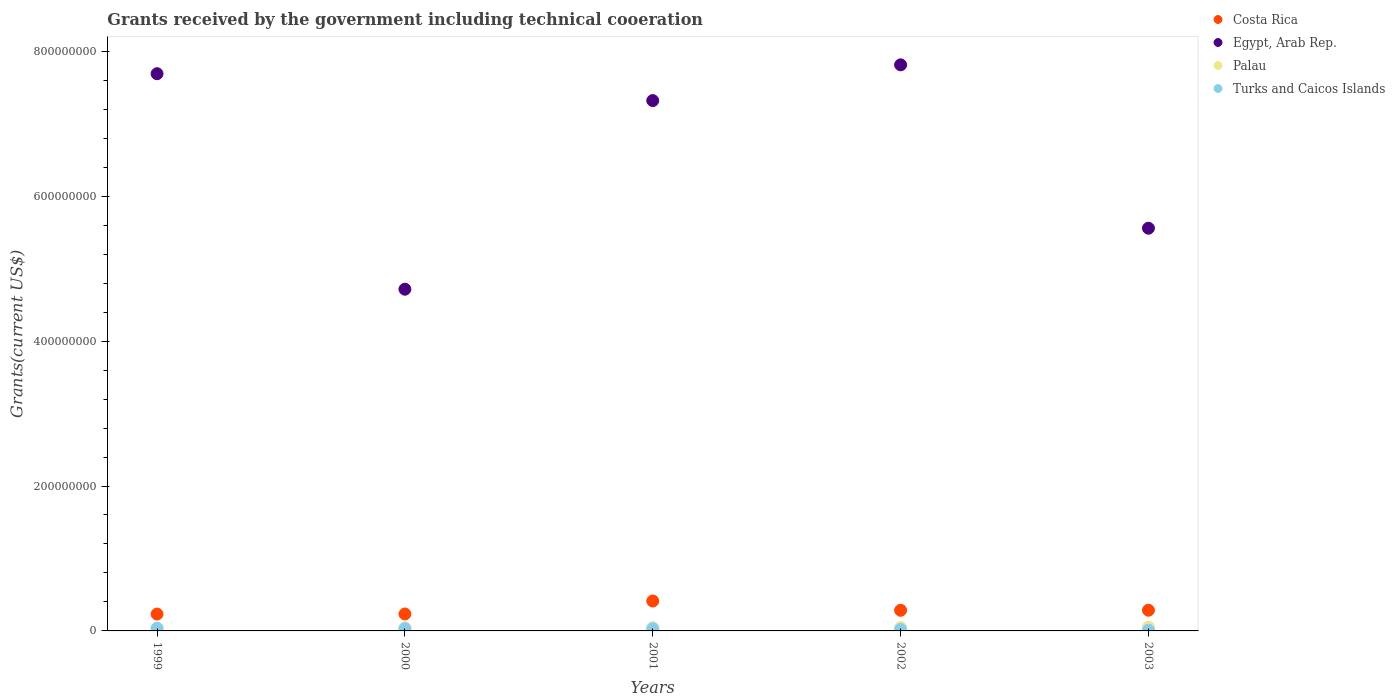Is the number of dotlines equal to the number of legend labels?
Ensure brevity in your answer.  Yes. What is the total grants received by the government in Turks and Caicos Islands in 2003?
Your answer should be very brief. 1.05e+06. Across all years, what is the maximum total grants received by the government in Egypt, Arab Rep.?
Offer a terse response. 7.81e+08. Across all years, what is the minimum total grants received by the government in Turks and Caicos Islands?
Your response must be concise. 1.05e+06. What is the total total grants received by the government in Palau in the graph?
Provide a short and direct response. 2.26e+07. What is the difference between the total grants received by the government in Turks and Caicos Islands in 2000 and that in 2001?
Your response must be concise. 1.60e+05. What is the difference between the total grants received by the government in Costa Rica in 2003 and the total grants received by the government in Egypt, Arab Rep. in 2001?
Give a very brief answer. -7.03e+08. What is the average total grants received by the government in Egypt, Arab Rep. per year?
Your answer should be compact. 6.62e+08. In the year 2000, what is the difference between the total grants received by the government in Costa Rica and total grants received by the government in Palau?
Your response must be concise. 1.92e+07. In how many years, is the total grants received by the government in Costa Rica greater than 680000000 US$?
Offer a very short reply. 0. What is the ratio of the total grants received by the government in Turks and Caicos Islands in 1999 to that in 2003?
Ensure brevity in your answer.  3.57. Is the difference between the total grants received by the government in Costa Rica in 1999 and 2000 greater than the difference between the total grants received by the government in Palau in 1999 and 2000?
Offer a terse response. Yes. What is the difference between the highest and the second highest total grants received by the government in Costa Rica?
Offer a terse response. 1.27e+07. What is the difference between the highest and the lowest total grants received by the government in Egypt, Arab Rep.?
Your response must be concise. 3.10e+08. In how many years, is the total grants received by the government in Turks and Caicos Islands greater than the average total grants received by the government in Turks and Caicos Islands taken over all years?
Provide a short and direct response. 3. Is it the case that in every year, the sum of the total grants received by the government in Costa Rica and total grants received by the government in Egypt, Arab Rep.  is greater than the total grants received by the government in Turks and Caicos Islands?
Keep it short and to the point. Yes. Does the total grants received by the government in Turks and Caicos Islands monotonically increase over the years?
Make the answer very short. No. Is the total grants received by the government in Egypt, Arab Rep. strictly less than the total grants received by the government in Palau over the years?
Offer a very short reply. No. How many dotlines are there?
Give a very brief answer. 4. How many years are there in the graph?
Keep it short and to the point. 5. What is the difference between two consecutive major ticks on the Y-axis?
Make the answer very short. 2.00e+08. Does the graph contain any zero values?
Offer a very short reply. No. Where does the legend appear in the graph?
Your answer should be compact. Top right. How many legend labels are there?
Offer a very short reply. 4. How are the legend labels stacked?
Your answer should be very brief. Vertical. What is the title of the graph?
Keep it short and to the point. Grants received by the government including technical cooeration. What is the label or title of the X-axis?
Offer a terse response. Years. What is the label or title of the Y-axis?
Give a very brief answer. Grants(current US$). What is the Grants(current US$) in Costa Rica in 1999?
Keep it short and to the point. 2.33e+07. What is the Grants(current US$) in Egypt, Arab Rep. in 1999?
Make the answer very short. 7.69e+08. What is the Grants(current US$) in Palau in 1999?
Provide a succinct answer. 3.66e+06. What is the Grants(current US$) of Turks and Caicos Islands in 1999?
Provide a short and direct response. 3.75e+06. What is the Grants(current US$) in Costa Rica in 2000?
Your answer should be compact. 2.34e+07. What is the Grants(current US$) of Egypt, Arab Rep. in 2000?
Offer a very short reply. 4.72e+08. What is the Grants(current US$) of Palau in 2000?
Keep it short and to the point. 4.24e+06. What is the Grants(current US$) in Turks and Caicos Islands in 2000?
Your response must be concise. 3.17e+06. What is the Grants(current US$) of Costa Rica in 2001?
Give a very brief answer. 4.13e+07. What is the Grants(current US$) in Egypt, Arab Rep. in 2001?
Offer a terse response. 7.32e+08. What is the Grants(current US$) in Palau in 2001?
Provide a short and direct response. 4.45e+06. What is the Grants(current US$) in Turks and Caicos Islands in 2001?
Provide a succinct answer. 3.01e+06. What is the Grants(current US$) of Costa Rica in 2002?
Your answer should be very brief. 2.85e+07. What is the Grants(current US$) of Egypt, Arab Rep. in 2002?
Ensure brevity in your answer.  7.81e+08. What is the Grants(current US$) of Palau in 2002?
Your response must be concise. 4.83e+06. What is the Grants(current US$) of Turks and Caicos Islands in 2002?
Your response must be concise. 2.01e+06. What is the Grants(current US$) of Costa Rica in 2003?
Provide a succinct answer. 2.86e+07. What is the Grants(current US$) in Egypt, Arab Rep. in 2003?
Your response must be concise. 5.56e+08. What is the Grants(current US$) in Palau in 2003?
Offer a terse response. 5.38e+06. What is the Grants(current US$) of Turks and Caicos Islands in 2003?
Your response must be concise. 1.05e+06. Across all years, what is the maximum Grants(current US$) in Costa Rica?
Your response must be concise. 4.13e+07. Across all years, what is the maximum Grants(current US$) of Egypt, Arab Rep.?
Offer a very short reply. 7.81e+08. Across all years, what is the maximum Grants(current US$) in Palau?
Offer a terse response. 5.38e+06. Across all years, what is the maximum Grants(current US$) in Turks and Caicos Islands?
Keep it short and to the point. 3.75e+06. Across all years, what is the minimum Grants(current US$) in Costa Rica?
Provide a short and direct response. 2.33e+07. Across all years, what is the minimum Grants(current US$) in Egypt, Arab Rep.?
Provide a short and direct response. 4.72e+08. Across all years, what is the minimum Grants(current US$) in Palau?
Your answer should be compact. 3.66e+06. Across all years, what is the minimum Grants(current US$) of Turks and Caicos Islands?
Offer a very short reply. 1.05e+06. What is the total Grants(current US$) of Costa Rica in the graph?
Offer a very short reply. 1.45e+08. What is the total Grants(current US$) of Egypt, Arab Rep. in the graph?
Provide a succinct answer. 3.31e+09. What is the total Grants(current US$) in Palau in the graph?
Offer a very short reply. 2.26e+07. What is the total Grants(current US$) in Turks and Caicos Islands in the graph?
Make the answer very short. 1.30e+07. What is the difference between the Grants(current US$) in Egypt, Arab Rep. in 1999 and that in 2000?
Your answer should be compact. 2.97e+08. What is the difference between the Grants(current US$) in Palau in 1999 and that in 2000?
Offer a very short reply. -5.80e+05. What is the difference between the Grants(current US$) of Turks and Caicos Islands in 1999 and that in 2000?
Keep it short and to the point. 5.80e+05. What is the difference between the Grants(current US$) in Costa Rica in 1999 and that in 2001?
Your response must be concise. -1.80e+07. What is the difference between the Grants(current US$) of Egypt, Arab Rep. in 1999 and that in 2001?
Keep it short and to the point. 3.71e+07. What is the difference between the Grants(current US$) of Palau in 1999 and that in 2001?
Your answer should be very brief. -7.90e+05. What is the difference between the Grants(current US$) in Turks and Caicos Islands in 1999 and that in 2001?
Provide a short and direct response. 7.40e+05. What is the difference between the Grants(current US$) in Costa Rica in 1999 and that in 2002?
Ensure brevity in your answer.  -5.23e+06. What is the difference between the Grants(current US$) of Egypt, Arab Rep. in 1999 and that in 2002?
Give a very brief answer. -1.22e+07. What is the difference between the Grants(current US$) in Palau in 1999 and that in 2002?
Your response must be concise. -1.17e+06. What is the difference between the Grants(current US$) of Turks and Caicos Islands in 1999 and that in 2002?
Offer a terse response. 1.74e+06. What is the difference between the Grants(current US$) in Costa Rica in 1999 and that in 2003?
Offer a terse response. -5.30e+06. What is the difference between the Grants(current US$) in Egypt, Arab Rep. in 1999 and that in 2003?
Your response must be concise. 2.13e+08. What is the difference between the Grants(current US$) of Palau in 1999 and that in 2003?
Give a very brief answer. -1.72e+06. What is the difference between the Grants(current US$) in Turks and Caicos Islands in 1999 and that in 2003?
Offer a terse response. 2.70e+06. What is the difference between the Grants(current US$) of Costa Rica in 2000 and that in 2001?
Give a very brief answer. -1.79e+07. What is the difference between the Grants(current US$) of Egypt, Arab Rep. in 2000 and that in 2001?
Give a very brief answer. -2.60e+08. What is the difference between the Grants(current US$) in Turks and Caicos Islands in 2000 and that in 2001?
Your answer should be compact. 1.60e+05. What is the difference between the Grants(current US$) of Costa Rica in 2000 and that in 2002?
Make the answer very short. -5.10e+06. What is the difference between the Grants(current US$) in Egypt, Arab Rep. in 2000 and that in 2002?
Provide a short and direct response. -3.10e+08. What is the difference between the Grants(current US$) in Palau in 2000 and that in 2002?
Give a very brief answer. -5.90e+05. What is the difference between the Grants(current US$) in Turks and Caicos Islands in 2000 and that in 2002?
Keep it short and to the point. 1.16e+06. What is the difference between the Grants(current US$) in Costa Rica in 2000 and that in 2003?
Offer a very short reply. -5.17e+06. What is the difference between the Grants(current US$) of Egypt, Arab Rep. in 2000 and that in 2003?
Provide a succinct answer. -8.42e+07. What is the difference between the Grants(current US$) in Palau in 2000 and that in 2003?
Your answer should be very brief. -1.14e+06. What is the difference between the Grants(current US$) of Turks and Caicos Islands in 2000 and that in 2003?
Offer a terse response. 2.12e+06. What is the difference between the Grants(current US$) of Costa Rica in 2001 and that in 2002?
Your answer should be compact. 1.28e+07. What is the difference between the Grants(current US$) in Egypt, Arab Rep. in 2001 and that in 2002?
Your answer should be compact. -4.93e+07. What is the difference between the Grants(current US$) in Palau in 2001 and that in 2002?
Provide a succinct answer. -3.80e+05. What is the difference between the Grants(current US$) in Turks and Caicos Islands in 2001 and that in 2002?
Your answer should be compact. 1.00e+06. What is the difference between the Grants(current US$) in Costa Rica in 2001 and that in 2003?
Your answer should be very brief. 1.27e+07. What is the difference between the Grants(current US$) of Egypt, Arab Rep. in 2001 and that in 2003?
Your answer should be very brief. 1.76e+08. What is the difference between the Grants(current US$) of Palau in 2001 and that in 2003?
Provide a short and direct response. -9.30e+05. What is the difference between the Grants(current US$) of Turks and Caicos Islands in 2001 and that in 2003?
Offer a very short reply. 1.96e+06. What is the difference between the Grants(current US$) in Egypt, Arab Rep. in 2002 and that in 2003?
Provide a succinct answer. 2.25e+08. What is the difference between the Grants(current US$) in Palau in 2002 and that in 2003?
Provide a succinct answer. -5.50e+05. What is the difference between the Grants(current US$) of Turks and Caicos Islands in 2002 and that in 2003?
Offer a terse response. 9.60e+05. What is the difference between the Grants(current US$) of Costa Rica in 1999 and the Grants(current US$) of Egypt, Arab Rep. in 2000?
Provide a short and direct response. -4.48e+08. What is the difference between the Grants(current US$) in Costa Rica in 1999 and the Grants(current US$) in Palau in 2000?
Keep it short and to the point. 1.90e+07. What is the difference between the Grants(current US$) in Costa Rica in 1999 and the Grants(current US$) in Turks and Caicos Islands in 2000?
Keep it short and to the point. 2.01e+07. What is the difference between the Grants(current US$) in Egypt, Arab Rep. in 1999 and the Grants(current US$) in Palau in 2000?
Give a very brief answer. 7.65e+08. What is the difference between the Grants(current US$) of Egypt, Arab Rep. in 1999 and the Grants(current US$) of Turks and Caicos Islands in 2000?
Provide a succinct answer. 7.66e+08. What is the difference between the Grants(current US$) in Palau in 1999 and the Grants(current US$) in Turks and Caicos Islands in 2000?
Offer a very short reply. 4.90e+05. What is the difference between the Grants(current US$) in Costa Rica in 1999 and the Grants(current US$) in Egypt, Arab Rep. in 2001?
Provide a succinct answer. -7.09e+08. What is the difference between the Grants(current US$) in Costa Rica in 1999 and the Grants(current US$) in Palau in 2001?
Provide a succinct answer. 1.88e+07. What is the difference between the Grants(current US$) of Costa Rica in 1999 and the Grants(current US$) of Turks and Caicos Islands in 2001?
Your answer should be very brief. 2.03e+07. What is the difference between the Grants(current US$) in Egypt, Arab Rep. in 1999 and the Grants(current US$) in Palau in 2001?
Provide a succinct answer. 7.65e+08. What is the difference between the Grants(current US$) of Egypt, Arab Rep. in 1999 and the Grants(current US$) of Turks and Caicos Islands in 2001?
Ensure brevity in your answer.  7.66e+08. What is the difference between the Grants(current US$) of Palau in 1999 and the Grants(current US$) of Turks and Caicos Islands in 2001?
Offer a very short reply. 6.50e+05. What is the difference between the Grants(current US$) of Costa Rica in 1999 and the Grants(current US$) of Egypt, Arab Rep. in 2002?
Offer a very short reply. -7.58e+08. What is the difference between the Grants(current US$) of Costa Rica in 1999 and the Grants(current US$) of Palau in 2002?
Keep it short and to the point. 1.84e+07. What is the difference between the Grants(current US$) of Costa Rica in 1999 and the Grants(current US$) of Turks and Caicos Islands in 2002?
Make the answer very short. 2.13e+07. What is the difference between the Grants(current US$) in Egypt, Arab Rep. in 1999 and the Grants(current US$) in Palau in 2002?
Offer a very short reply. 7.64e+08. What is the difference between the Grants(current US$) of Egypt, Arab Rep. in 1999 and the Grants(current US$) of Turks and Caicos Islands in 2002?
Offer a terse response. 7.67e+08. What is the difference between the Grants(current US$) in Palau in 1999 and the Grants(current US$) in Turks and Caicos Islands in 2002?
Provide a succinct answer. 1.65e+06. What is the difference between the Grants(current US$) in Costa Rica in 1999 and the Grants(current US$) in Egypt, Arab Rep. in 2003?
Make the answer very short. -5.33e+08. What is the difference between the Grants(current US$) in Costa Rica in 1999 and the Grants(current US$) in Palau in 2003?
Your answer should be very brief. 1.79e+07. What is the difference between the Grants(current US$) in Costa Rica in 1999 and the Grants(current US$) in Turks and Caicos Islands in 2003?
Make the answer very short. 2.22e+07. What is the difference between the Grants(current US$) of Egypt, Arab Rep. in 1999 and the Grants(current US$) of Palau in 2003?
Ensure brevity in your answer.  7.64e+08. What is the difference between the Grants(current US$) of Egypt, Arab Rep. in 1999 and the Grants(current US$) of Turks and Caicos Islands in 2003?
Offer a very short reply. 7.68e+08. What is the difference between the Grants(current US$) of Palau in 1999 and the Grants(current US$) of Turks and Caicos Islands in 2003?
Give a very brief answer. 2.61e+06. What is the difference between the Grants(current US$) in Costa Rica in 2000 and the Grants(current US$) in Egypt, Arab Rep. in 2001?
Make the answer very short. -7.09e+08. What is the difference between the Grants(current US$) in Costa Rica in 2000 and the Grants(current US$) in Palau in 2001?
Your answer should be compact. 1.90e+07. What is the difference between the Grants(current US$) of Costa Rica in 2000 and the Grants(current US$) of Turks and Caicos Islands in 2001?
Give a very brief answer. 2.04e+07. What is the difference between the Grants(current US$) in Egypt, Arab Rep. in 2000 and the Grants(current US$) in Palau in 2001?
Offer a very short reply. 4.67e+08. What is the difference between the Grants(current US$) in Egypt, Arab Rep. in 2000 and the Grants(current US$) in Turks and Caicos Islands in 2001?
Your answer should be very brief. 4.69e+08. What is the difference between the Grants(current US$) in Palau in 2000 and the Grants(current US$) in Turks and Caicos Islands in 2001?
Make the answer very short. 1.23e+06. What is the difference between the Grants(current US$) in Costa Rica in 2000 and the Grants(current US$) in Egypt, Arab Rep. in 2002?
Your response must be concise. -7.58e+08. What is the difference between the Grants(current US$) in Costa Rica in 2000 and the Grants(current US$) in Palau in 2002?
Provide a succinct answer. 1.86e+07. What is the difference between the Grants(current US$) in Costa Rica in 2000 and the Grants(current US$) in Turks and Caicos Islands in 2002?
Your answer should be very brief. 2.14e+07. What is the difference between the Grants(current US$) in Egypt, Arab Rep. in 2000 and the Grants(current US$) in Palau in 2002?
Ensure brevity in your answer.  4.67e+08. What is the difference between the Grants(current US$) in Egypt, Arab Rep. in 2000 and the Grants(current US$) in Turks and Caicos Islands in 2002?
Your answer should be very brief. 4.70e+08. What is the difference between the Grants(current US$) of Palau in 2000 and the Grants(current US$) of Turks and Caicos Islands in 2002?
Your answer should be very brief. 2.23e+06. What is the difference between the Grants(current US$) in Costa Rica in 2000 and the Grants(current US$) in Egypt, Arab Rep. in 2003?
Provide a succinct answer. -5.32e+08. What is the difference between the Grants(current US$) of Costa Rica in 2000 and the Grants(current US$) of Palau in 2003?
Provide a short and direct response. 1.80e+07. What is the difference between the Grants(current US$) of Costa Rica in 2000 and the Grants(current US$) of Turks and Caicos Islands in 2003?
Keep it short and to the point. 2.24e+07. What is the difference between the Grants(current US$) in Egypt, Arab Rep. in 2000 and the Grants(current US$) in Palau in 2003?
Provide a succinct answer. 4.66e+08. What is the difference between the Grants(current US$) of Egypt, Arab Rep. in 2000 and the Grants(current US$) of Turks and Caicos Islands in 2003?
Your answer should be very brief. 4.71e+08. What is the difference between the Grants(current US$) in Palau in 2000 and the Grants(current US$) in Turks and Caicos Islands in 2003?
Provide a short and direct response. 3.19e+06. What is the difference between the Grants(current US$) of Costa Rica in 2001 and the Grants(current US$) of Egypt, Arab Rep. in 2002?
Your answer should be very brief. -7.40e+08. What is the difference between the Grants(current US$) of Costa Rica in 2001 and the Grants(current US$) of Palau in 2002?
Keep it short and to the point. 3.64e+07. What is the difference between the Grants(current US$) in Costa Rica in 2001 and the Grants(current US$) in Turks and Caicos Islands in 2002?
Ensure brevity in your answer.  3.93e+07. What is the difference between the Grants(current US$) in Egypt, Arab Rep. in 2001 and the Grants(current US$) in Palau in 2002?
Your response must be concise. 7.27e+08. What is the difference between the Grants(current US$) in Egypt, Arab Rep. in 2001 and the Grants(current US$) in Turks and Caicos Islands in 2002?
Keep it short and to the point. 7.30e+08. What is the difference between the Grants(current US$) of Palau in 2001 and the Grants(current US$) of Turks and Caicos Islands in 2002?
Give a very brief answer. 2.44e+06. What is the difference between the Grants(current US$) in Costa Rica in 2001 and the Grants(current US$) in Egypt, Arab Rep. in 2003?
Your answer should be compact. -5.15e+08. What is the difference between the Grants(current US$) of Costa Rica in 2001 and the Grants(current US$) of Palau in 2003?
Provide a short and direct response. 3.59e+07. What is the difference between the Grants(current US$) of Costa Rica in 2001 and the Grants(current US$) of Turks and Caicos Islands in 2003?
Provide a short and direct response. 4.02e+07. What is the difference between the Grants(current US$) in Egypt, Arab Rep. in 2001 and the Grants(current US$) in Palau in 2003?
Offer a terse response. 7.27e+08. What is the difference between the Grants(current US$) of Egypt, Arab Rep. in 2001 and the Grants(current US$) of Turks and Caicos Islands in 2003?
Offer a very short reply. 7.31e+08. What is the difference between the Grants(current US$) of Palau in 2001 and the Grants(current US$) of Turks and Caicos Islands in 2003?
Your response must be concise. 3.40e+06. What is the difference between the Grants(current US$) in Costa Rica in 2002 and the Grants(current US$) in Egypt, Arab Rep. in 2003?
Provide a short and direct response. -5.27e+08. What is the difference between the Grants(current US$) in Costa Rica in 2002 and the Grants(current US$) in Palau in 2003?
Offer a very short reply. 2.31e+07. What is the difference between the Grants(current US$) in Costa Rica in 2002 and the Grants(current US$) in Turks and Caicos Islands in 2003?
Provide a succinct answer. 2.74e+07. What is the difference between the Grants(current US$) of Egypt, Arab Rep. in 2002 and the Grants(current US$) of Palau in 2003?
Keep it short and to the point. 7.76e+08. What is the difference between the Grants(current US$) in Egypt, Arab Rep. in 2002 and the Grants(current US$) in Turks and Caicos Islands in 2003?
Offer a terse response. 7.80e+08. What is the difference between the Grants(current US$) in Palau in 2002 and the Grants(current US$) in Turks and Caicos Islands in 2003?
Your response must be concise. 3.78e+06. What is the average Grants(current US$) in Costa Rica per year?
Your answer should be compact. 2.90e+07. What is the average Grants(current US$) of Egypt, Arab Rep. per year?
Give a very brief answer. 6.62e+08. What is the average Grants(current US$) of Palau per year?
Provide a succinct answer. 4.51e+06. What is the average Grants(current US$) in Turks and Caicos Islands per year?
Offer a terse response. 2.60e+06. In the year 1999, what is the difference between the Grants(current US$) in Costa Rica and Grants(current US$) in Egypt, Arab Rep.?
Your answer should be compact. -7.46e+08. In the year 1999, what is the difference between the Grants(current US$) in Costa Rica and Grants(current US$) in Palau?
Ensure brevity in your answer.  1.96e+07. In the year 1999, what is the difference between the Grants(current US$) in Costa Rica and Grants(current US$) in Turks and Caicos Islands?
Make the answer very short. 1.95e+07. In the year 1999, what is the difference between the Grants(current US$) in Egypt, Arab Rep. and Grants(current US$) in Palau?
Offer a very short reply. 7.65e+08. In the year 1999, what is the difference between the Grants(current US$) in Egypt, Arab Rep. and Grants(current US$) in Turks and Caicos Islands?
Ensure brevity in your answer.  7.65e+08. In the year 1999, what is the difference between the Grants(current US$) of Palau and Grants(current US$) of Turks and Caicos Islands?
Offer a terse response. -9.00e+04. In the year 2000, what is the difference between the Grants(current US$) of Costa Rica and Grants(current US$) of Egypt, Arab Rep.?
Give a very brief answer. -4.48e+08. In the year 2000, what is the difference between the Grants(current US$) in Costa Rica and Grants(current US$) in Palau?
Offer a very short reply. 1.92e+07. In the year 2000, what is the difference between the Grants(current US$) of Costa Rica and Grants(current US$) of Turks and Caicos Islands?
Provide a succinct answer. 2.02e+07. In the year 2000, what is the difference between the Grants(current US$) of Egypt, Arab Rep. and Grants(current US$) of Palau?
Offer a terse response. 4.67e+08. In the year 2000, what is the difference between the Grants(current US$) in Egypt, Arab Rep. and Grants(current US$) in Turks and Caicos Islands?
Offer a very short reply. 4.68e+08. In the year 2000, what is the difference between the Grants(current US$) in Palau and Grants(current US$) in Turks and Caicos Islands?
Your response must be concise. 1.07e+06. In the year 2001, what is the difference between the Grants(current US$) of Costa Rica and Grants(current US$) of Egypt, Arab Rep.?
Offer a terse response. -6.91e+08. In the year 2001, what is the difference between the Grants(current US$) in Costa Rica and Grants(current US$) in Palau?
Provide a succinct answer. 3.68e+07. In the year 2001, what is the difference between the Grants(current US$) in Costa Rica and Grants(current US$) in Turks and Caicos Islands?
Give a very brief answer. 3.83e+07. In the year 2001, what is the difference between the Grants(current US$) of Egypt, Arab Rep. and Grants(current US$) of Palau?
Give a very brief answer. 7.28e+08. In the year 2001, what is the difference between the Grants(current US$) in Egypt, Arab Rep. and Grants(current US$) in Turks and Caicos Islands?
Give a very brief answer. 7.29e+08. In the year 2001, what is the difference between the Grants(current US$) of Palau and Grants(current US$) of Turks and Caicos Islands?
Give a very brief answer. 1.44e+06. In the year 2002, what is the difference between the Grants(current US$) of Costa Rica and Grants(current US$) of Egypt, Arab Rep.?
Ensure brevity in your answer.  -7.53e+08. In the year 2002, what is the difference between the Grants(current US$) in Costa Rica and Grants(current US$) in Palau?
Ensure brevity in your answer.  2.37e+07. In the year 2002, what is the difference between the Grants(current US$) of Costa Rica and Grants(current US$) of Turks and Caicos Islands?
Give a very brief answer. 2.65e+07. In the year 2002, what is the difference between the Grants(current US$) of Egypt, Arab Rep. and Grants(current US$) of Palau?
Keep it short and to the point. 7.76e+08. In the year 2002, what is the difference between the Grants(current US$) of Egypt, Arab Rep. and Grants(current US$) of Turks and Caicos Islands?
Ensure brevity in your answer.  7.79e+08. In the year 2002, what is the difference between the Grants(current US$) in Palau and Grants(current US$) in Turks and Caicos Islands?
Your answer should be compact. 2.82e+06. In the year 2003, what is the difference between the Grants(current US$) in Costa Rica and Grants(current US$) in Egypt, Arab Rep.?
Offer a terse response. -5.27e+08. In the year 2003, what is the difference between the Grants(current US$) in Costa Rica and Grants(current US$) in Palau?
Make the answer very short. 2.32e+07. In the year 2003, what is the difference between the Grants(current US$) of Costa Rica and Grants(current US$) of Turks and Caicos Islands?
Keep it short and to the point. 2.75e+07. In the year 2003, what is the difference between the Grants(current US$) of Egypt, Arab Rep. and Grants(current US$) of Palau?
Your response must be concise. 5.50e+08. In the year 2003, what is the difference between the Grants(current US$) in Egypt, Arab Rep. and Grants(current US$) in Turks and Caicos Islands?
Provide a short and direct response. 5.55e+08. In the year 2003, what is the difference between the Grants(current US$) in Palau and Grants(current US$) in Turks and Caicos Islands?
Your response must be concise. 4.33e+06. What is the ratio of the Grants(current US$) in Egypt, Arab Rep. in 1999 to that in 2000?
Your answer should be very brief. 1.63. What is the ratio of the Grants(current US$) of Palau in 1999 to that in 2000?
Your answer should be compact. 0.86. What is the ratio of the Grants(current US$) of Turks and Caicos Islands in 1999 to that in 2000?
Ensure brevity in your answer.  1.18. What is the ratio of the Grants(current US$) of Costa Rica in 1999 to that in 2001?
Make the answer very short. 0.56. What is the ratio of the Grants(current US$) of Egypt, Arab Rep. in 1999 to that in 2001?
Your answer should be compact. 1.05. What is the ratio of the Grants(current US$) in Palau in 1999 to that in 2001?
Ensure brevity in your answer.  0.82. What is the ratio of the Grants(current US$) of Turks and Caicos Islands in 1999 to that in 2001?
Keep it short and to the point. 1.25. What is the ratio of the Grants(current US$) of Costa Rica in 1999 to that in 2002?
Make the answer very short. 0.82. What is the ratio of the Grants(current US$) of Egypt, Arab Rep. in 1999 to that in 2002?
Ensure brevity in your answer.  0.98. What is the ratio of the Grants(current US$) in Palau in 1999 to that in 2002?
Provide a short and direct response. 0.76. What is the ratio of the Grants(current US$) of Turks and Caicos Islands in 1999 to that in 2002?
Make the answer very short. 1.87. What is the ratio of the Grants(current US$) in Costa Rica in 1999 to that in 2003?
Ensure brevity in your answer.  0.81. What is the ratio of the Grants(current US$) in Egypt, Arab Rep. in 1999 to that in 2003?
Give a very brief answer. 1.38. What is the ratio of the Grants(current US$) of Palau in 1999 to that in 2003?
Your answer should be very brief. 0.68. What is the ratio of the Grants(current US$) in Turks and Caicos Islands in 1999 to that in 2003?
Your answer should be very brief. 3.57. What is the ratio of the Grants(current US$) of Costa Rica in 2000 to that in 2001?
Offer a very short reply. 0.57. What is the ratio of the Grants(current US$) in Egypt, Arab Rep. in 2000 to that in 2001?
Keep it short and to the point. 0.64. What is the ratio of the Grants(current US$) of Palau in 2000 to that in 2001?
Ensure brevity in your answer.  0.95. What is the ratio of the Grants(current US$) in Turks and Caicos Islands in 2000 to that in 2001?
Offer a terse response. 1.05. What is the ratio of the Grants(current US$) of Costa Rica in 2000 to that in 2002?
Your answer should be compact. 0.82. What is the ratio of the Grants(current US$) of Egypt, Arab Rep. in 2000 to that in 2002?
Your response must be concise. 0.6. What is the ratio of the Grants(current US$) in Palau in 2000 to that in 2002?
Provide a short and direct response. 0.88. What is the ratio of the Grants(current US$) of Turks and Caicos Islands in 2000 to that in 2002?
Offer a terse response. 1.58. What is the ratio of the Grants(current US$) in Costa Rica in 2000 to that in 2003?
Make the answer very short. 0.82. What is the ratio of the Grants(current US$) of Egypt, Arab Rep. in 2000 to that in 2003?
Keep it short and to the point. 0.85. What is the ratio of the Grants(current US$) of Palau in 2000 to that in 2003?
Make the answer very short. 0.79. What is the ratio of the Grants(current US$) of Turks and Caicos Islands in 2000 to that in 2003?
Provide a succinct answer. 3.02. What is the ratio of the Grants(current US$) in Costa Rica in 2001 to that in 2002?
Provide a succinct answer. 1.45. What is the ratio of the Grants(current US$) in Egypt, Arab Rep. in 2001 to that in 2002?
Keep it short and to the point. 0.94. What is the ratio of the Grants(current US$) in Palau in 2001 to that in 2002?
Your answer should be compact. 0.92. What is the ratio of the Grants(current US$) in Turks and Caicos Islands in 2001 to that in 2002?
Provide a succinct answer. 1.5. What is the ratio of the Grants(current US$) in Costa Rica in 2001 to that in 2003?
Give a very brief answer. 1.44. What is the ratio of the Grants(current US$) of Egypt, Arab Rep. in 2001 to that in 2003?
Provide a short and direct response. 1.32. What is the ratio of the Grants(current US$) of Palau in 2001 to that in 2003?
Your answer should be compact. 0.83. What is the ratio of the Grants(current US$) in Turks and Caicos Islands in 2001 to that in 2003?
Your response must be concise. 2.87. What is the ratio of the Grants(current US$) of Egypt, Arab Rep. in 2002 to that in 2003?
Give a very brief answer. 1.41. What is the ratio of the Grants(current US$) in Palau in 2002 to that in 2003?
Offer a very short reply. 0.9. What is the ratio of the Grants(current US$) in Turks and Caicos Islands in 2002 to that in 2003?
Make the answer very short. 1.91. What is the difference between the highest and the second highest Grants(current US$) of Costa Rica?
Your response must be concise. 1.27e+07. What is the difference between the highest and the second highest Grants(current US$) of Egypt, Arab Rep.?
Keep it short and to the point. 1.22e+07. What is the difference between the highest and the second highest Grants(current US$) of Turks and Caicos Islands?
Your response must be concise. 5.80e+05. What is the difference between the highest and the lowest Grants(current US$) in Costa Rica?
Ensure brevity in your answer.  1.80e+07. What is the difference between the highest and the lowest Grants(current US$) in Egypt, Arab Rep.?
Your answer should be compact. 3.10e+08. What is the difference between the highest and the lowest Grants(current US$) of Palau?
Give a very brief answer. 1.72e+06. What is the difference between the highest and the lowest Grants(current US$) of Turks and Caicos Islands?
Make the answer very short. 2.70e+06. 